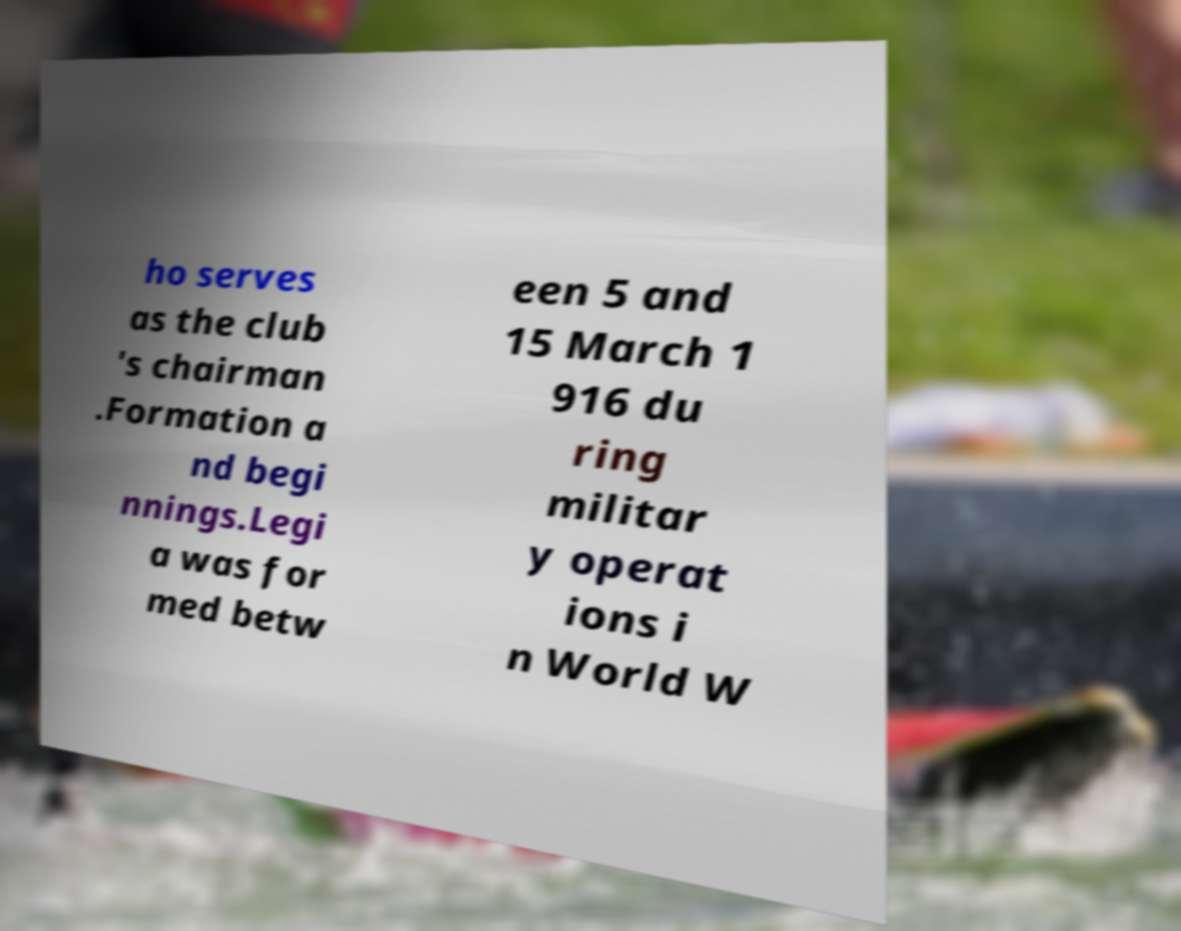Please read and relay the text visible in this image. What does it say? ho serves as the club 's chairman .Formation a nd begi nnings.Legi a was for med betw een 5 and 15 March 1 916 du ring militar y operat ions i n World W 